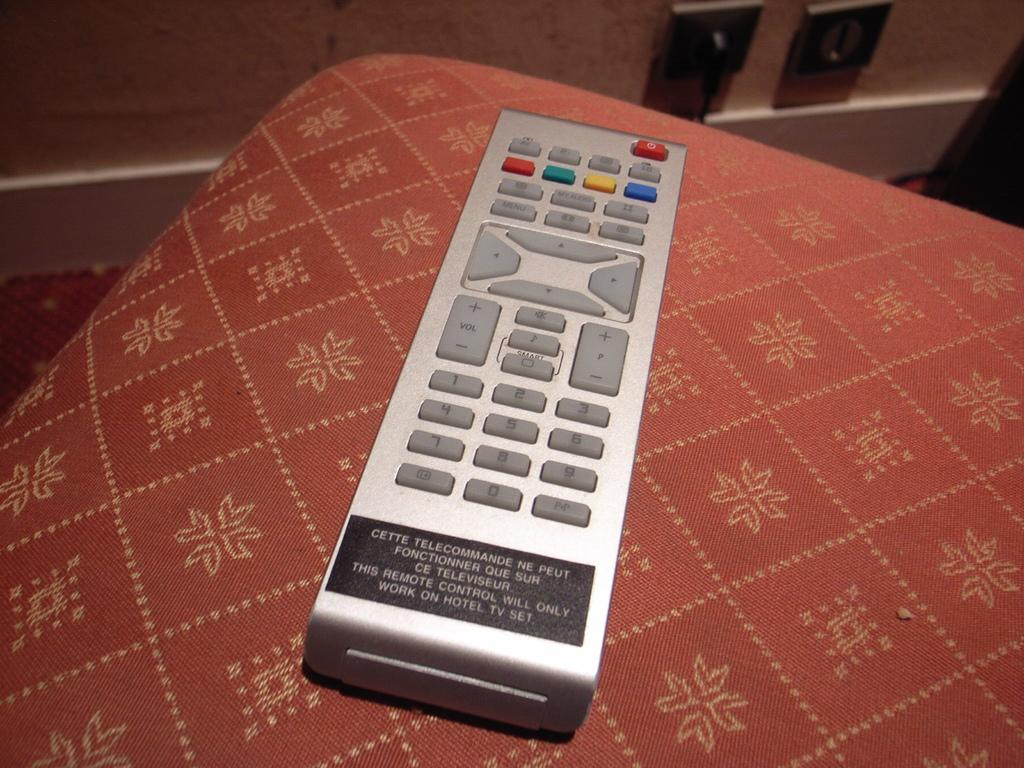<image>
Render a clear and concise summary of the photo. A television remote control has a sticker on it which says it will only work with a hotel TV. 